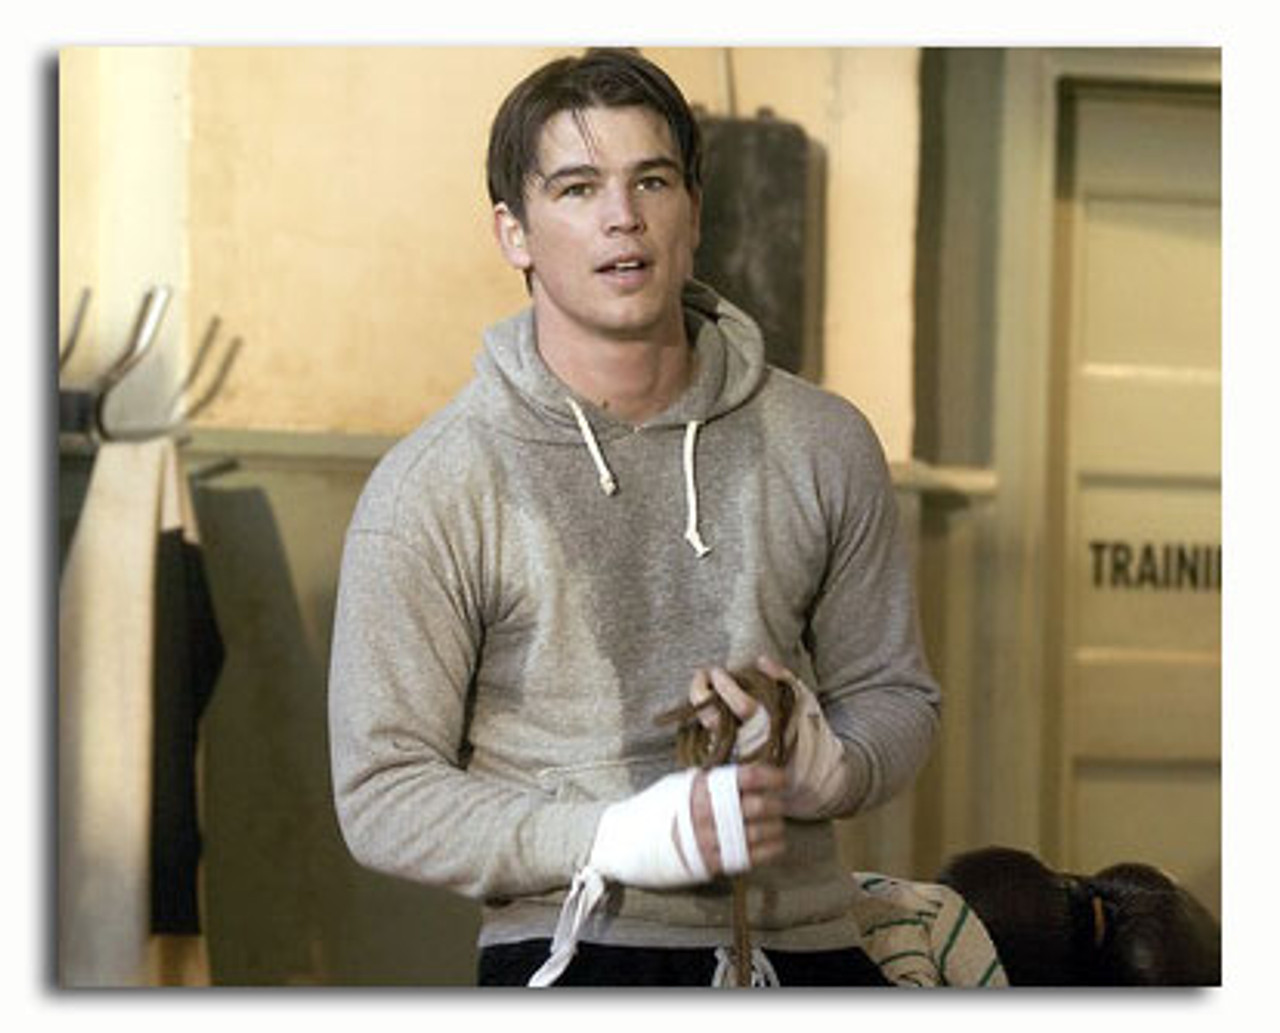Given the gym setting, what kind of training might this person be involved in? Considering the gym environment and the presence of boxing gloves and a punching bag, it's likely that the person is training for boxing. This training might include various activities such as shadowboxing, hitting the bag, sparring, and physical conditioning to improve strength, agility, and endurance. 